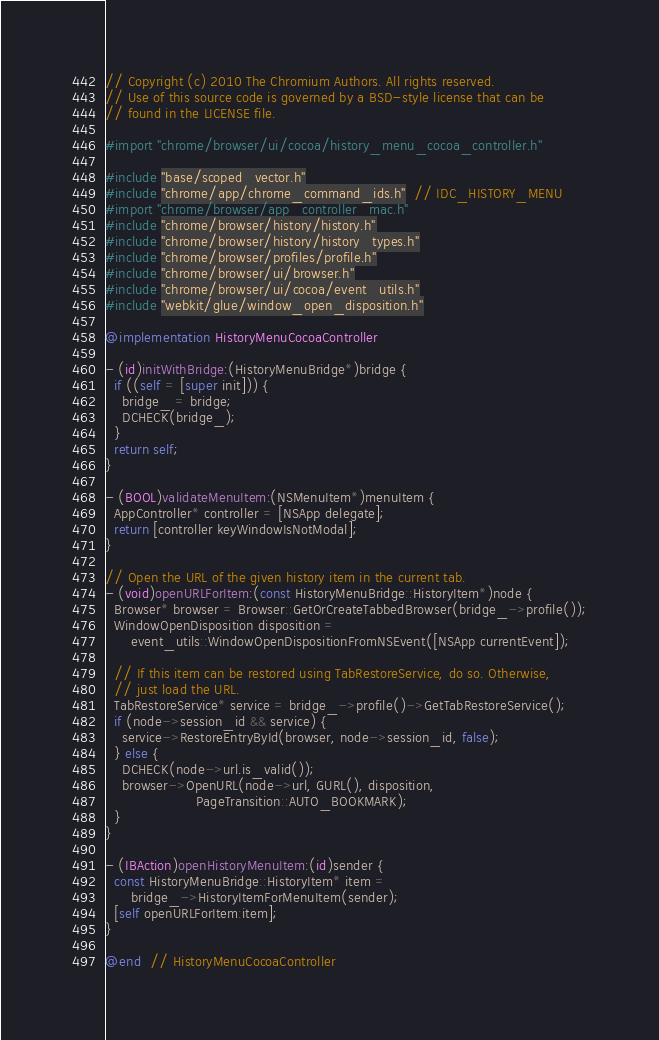Convert code to text. <code><loc_0><loc_0><loc_500><loc_500><_ObjectiveC_>// Copyright (c) 2010 The Chromium Authors. All rights reserved.
// Use of this source code is governed by a BSD-style license that can be
// found in the LICENSE file.

#import "chrome/browser/ui/cocoa/history_menu_cocoa_controller.h"

#include "base/scoped_vector.h"
#include "chrome/app/chrome_command_ids.h"  // IDC_HISTORY_MENU
#import "chrome/browser/app_controller_mac.h"
#include "chrome/browser/history/history.h"
#include "chrome/browser/history/history_types.h"
#include "chrome/browser/profiles/profile.h"
#include "chrome/browser/ui/browser.h"
#include "chrome/browser/ui/cocoa/event_utils.h"
#include "webkit/glue/window_open_disposition.h"

@implementation HistoryMenuCocoaController

- (id)initWithBridge:(HistoryMenuBridge*)bridge {
  if ((self = [super init])) {
    bridge_ = bridge;
    DCHECK(bridge_);
  }
  return self;
}

- (BOOL)validateMenuItem:(NSMenuItem*)menuItem {
  AppController* controller = [NSApp delegate];
  return [controller keyWindowIsNotModal];
}

// Open the URL of the given history item in the current tab.
- (void)openURLForItem:(const HistoryMenuBridge::HistoryItem*)node {
  Browser* browser = Browser::GetOrCreateTabbedBrowser(bridge_->profile());
  WindowOpenDisposition disposition =
      event_utils::WindowOpenDispositionFromNSEvent([NSApp currentEvent]);

  // If this item can be restored using TabRestoreService, do so. Otherwise,
  // just load the URL.
  TabRestoreService* service = bridge_->profile()->GetTabRestoreService();
  if (node->session_id && service) {
    service->RestoreEntryById(browser, node->session_id, false);
  } else {
    DCHECK(node->url.is_valid());
    browser->OpenURL(node->url, GURL(), disposition,
                     PageTransition::AUTO_BOOKMARK);
  }
}

- (IBAction)openHistoryMenuItem:(id)sender {
  const HistoryMenuBridge::HistoryItem* item =
      bridge_->HistoryItemForMenuItem(sender);
  [self openURLForItem:item];
}

@end  // HistoryMenuCocoaController
</code> 